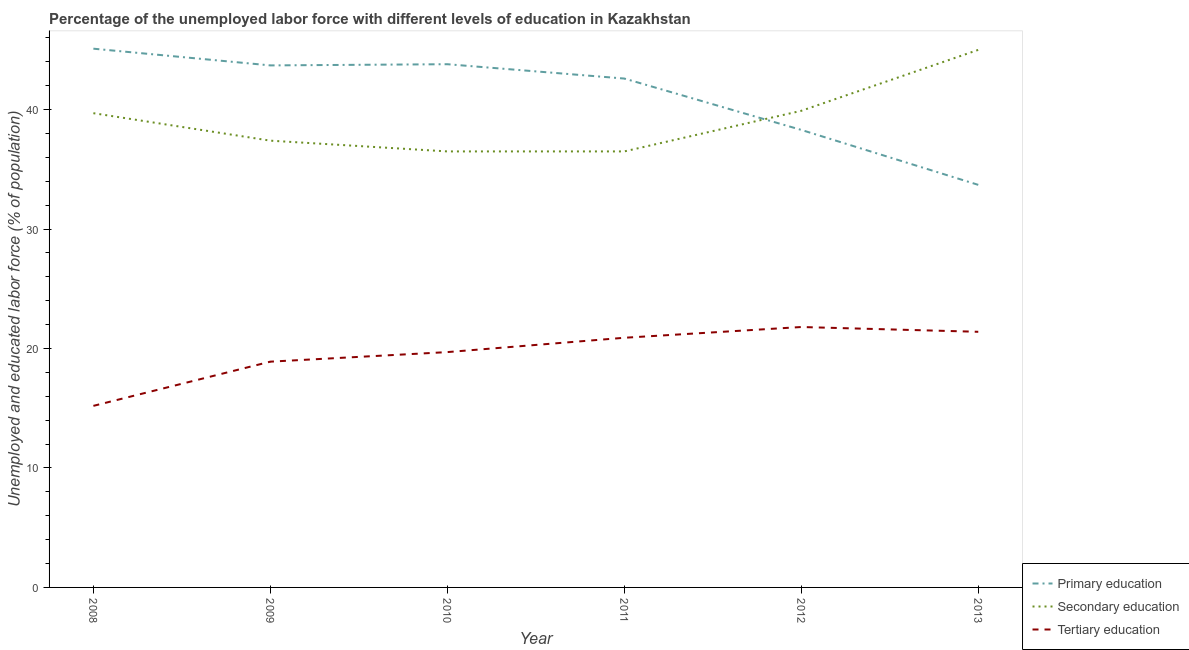Does the line corresponding to percentage of labor force who received tertiary education intersect with the line corresponding to percentage of labor force who received secondary education?
Offer a terse response. No. Is the number of lines equal to the number of legend labels?
Give a very brief answer. Yes. What is the percentage of labor force who received primary education in 2008?
Provide a short and direct response. 45.1. Across all years, what is the maximum percentage of labor force who received tertiary education?
Make the answer very short. 21.8. Across all years, what is the minimum percentage of labor force who received tertiary education?
Ensure brevity in your answer.  15.2. In which year was the percentage of labor force who received primary education maximum?
Offer a very short reply. 2008. What is the total percentage of labor force who received primary education in the graph?
Your answer should be very brief. 247.2. What is the difference between the percentage of labor force who received primary education in 2012 and that in 2013?
Ensure brevity in your answer.  4.6. What is the difference between the percentage of labor force who received tertiary education in 2012 and the percentage of labor force who received secondary education in 2009?
Your answer should be compact. -15.6. What is the average percentage of labor force who received secondary education per year?
Provide a succinct answer. 39.17. In the year 2011, what is the difference between the percentage of labor force who received secondary education and percentage of labor force who received primary education?
Give a very brief answer. -6.1. In how many years, is the percentage of labor force who received secondary education greater than 4 %?
Keep it short and to the point. 6. What is the ratio of the percentage of labor force who received tertiary education in 2010 to that in 2012?
Make the answer very short. 0.9. What is the difference between the highest and the second highest percentage of labor force who received tertiary education?
Give a very brief answer. 0.4. What is the difference between the highest and the lowest percentage of labor force who received tertiary education?
Offer a terse response. 6.6. In how many years, is the percentage of labor force who received primary education greater than the average percentage of labor force who received primary education taken over all years?
Ensure brevity in your answer.  4. Is the sum of the percentage of labor force who received secondary education in 2010 and 2011 greater than the maximum percentage of labor force who received tertiary education across all years?
Your answer should be very brief. Yes. Is it the case that in every year, the sum of the percentage of labor force who received primary education and percentage of labor force who received secondary education is greater than the percentage of labor force who received tertiary education?
Provide a short and direct response. Yes. How many lines are there?
Offer a very short reply. 3. How many years are there in the graph?
Give a very brief answer. 6. Are the values on the major ticks of Y-axis written in scientific E-notation?
Provide a short and direct response. No. Does the graph contain any zero values?
Give a very brief answer. No. Where does the legend appear in the graph?
Your answer should be compact. Bottom right. How many legend labels are there?
Offer a terse response. 3. What is the title of the graph?
Provide a short and direct response. Percentage of the unemployed labor force with different levels of education in Kazakhstan. What is the label or title of the Y-axis?
Offer a very short reply. Unemployed and educated labor force (% of population). What is the Unemployed and educated labor force (% of population) of Primary education in 2008?
Keep it short and to the point. 45.1. What is the Unemployed and educated labor force (% of population) in Secondary education in 2008?
Ensure brevity in your answer.  39.7. What is the Unemployed and educated labor force (% of population) in Tertiary education in 2008?
Offer a terse response. 15.2. What is the Unemployed and educated labor force (% of population) of Primary education in 2009?
Your answer should be compact. 43.7. What is the Unemployed and educated labor force (% of population) of Secondary education in 2009?
Offer a very short reply. 37.4. What is the Unemployed and educated labor force (% of population) in Tertiary education in 2009?
Your answer should be compact. 18.9. What is the Unemployed and educated labor force (% of population) in Primary education in 2010?
Provide a short and direct response. 43.8. What is the Unemployed and educated labor force (% of population) of Secondary education in 2010?
Ensure brevity in your answer.  36.5. What is the Unemployed and educated labor force (% of population) of Tertiary education in 2010?
Your response must be concise. 19.7. What is the Unemployed and educated labor force (% of population) of Primary education in 2011?
Offer a very short reply. 42.6. What is the Unemployed and educated labor force (% of population) in Secondary education in 2011?
Give a very brief answer. 36.5. What is the Unemployed and educated labor force (% of population) of Tertiary education in 2011?
Offer a very short reply. 20.9. What is the Unemployed and educated labor force (% of population) in Primary education in 2012?
Your answer should be very brief. 38.3. What is the Unemployed and educated labor force (% of population) in Secondary education in 2012?
Your answer should be very brief. 39.9. What is the Unemployed and educated labor force (% of population) of Tertiary education in 2012?
Provide a short and direct response. 21.8. What is the Unemployed and educated labor force (% of population) of Primary education in 2013?
Provide a short and direct response. 33.7. What is the Unemployed and educated labor force (% of population) in Secondary education in 2013?
Make the answer very short. 45. What is the Unemployed and educated labor force (% of population) in Tertiary education in 2013?
Make the answer very short. 21.4. Across all years, what is the maximum Unemployed and educated labor force (% of population) of Primary education?
Your response must be concise. 45.1. Across all years, what is the maximum Unemployed and educated labor force (% of population) of Secondary education?
Make the answer very short. 45. Across all years, what is the maximum Unemployed and educated labor force (% of population) of Tertiary education?
Your response must be concise. 21.8. Across all years, what is the minimum Unemployed and educated labor force (% of population) in Primary education?
Keep it short and to the point. 33.7. Across all years, what is the minimum Unemployed and educated labor force (% of population) of Secondary education?
Offer a very short reply. 36.5. Across all years, what is the minimum Unemployed and educated labor force (% of population) in Tertiary education?
Make the answer very short. 15.2. What is the total Unemployed and educated labor force (% of population) in Primary education in the graph?
Provide a succinct answer. 247.2. What is the total Unemployed and educated labor force (% of population) in Secondary education in the graph?
Provide a succinct answer. 235. What is the total Unemployed and educated labor force (% of population) of Tertiary education in the graph?
Provide a succinct answer. 117.9. What is the difference between the Unemployed and educated labor force (% of population) in Primary education in 2008 and that in 2009?
Your answer should be compact. 1.4. What is the difference between the Unemployed and educated labor force (% of population) in Secondary education in 2008 and that in 2009?
Make the answer very short. 2.3. What is the difference between the Unemployed and educated labor force (% of population) in Primary education in 2008 and that in 2010?
Give a very brief answer. 1.3. What is the difference between the Unemployed and educated labor force (% of population) of Tertiary education in 2008 and that in 2010?
Offer a very short reply. -4.5. What is the difference between the Unemployed and educated labor force (% of population) in Primary education in 2008 and that in 2011?
Make the answer very short. 2.5. What is the difference between the Unemployed and educated labor force (% of population) in Secondary education in 2008 and that in 2011?
Offer a very short reply. 3.2. What is the difference between the Unemployed and educated labor force (% of population) of Secondary education in 2008 and that in 2013?
Provide a succinct answer. -5.3. What is the difference between the Unemployed and educated labor force (% of population) of Primary education in 2009 and that in 2010?
Offer a terse response. -0.1. What is the difference between the Unemployed and educated labor force (% of population) in Secondary education in 2009 and that in 2010?
Provide a succinct answer. 0.9. What is the difference between the Unemployed and educated labor force (% of population) of Tertiary education in 2009 and that in 2010?
Offer a terse response. -0.8. What is the difference between the Unemployed and educated labor force (% of population) of Primary education in 2009 and that in 2012?
Ensure brevity in your answer.  5.4. What is the difference between the Unemployed and educated labor force (% of population) of Secondary education in 2009 and that in 2012?
Offer a terse response. -2.5. What is the difference between the Unemployed and educated labor force (% of population) of Secondary education in 2010 and that in 2011?
Ensure brevity in your answer.  0. What is the difference between the Unemployed and educated labor force (% of population) of Primary education in 2010 and that in 2012?
Provide a short and direct response. 5.5. What is the difference between the Unemployed and educated labor force (% of population) of Secondary education in 2010 and that in 2012?
Your answer should be very brief. -3.4. What is the difference between the Unemployed and educated labor force (% of population) in Tertiary education in 2010 and that in 2012?
Provide a succinct answer. -2.1. What is the difference between the Unemployed and educated labor force (% of population) in Tertiary education in 2010 and that in 2013?
Offer a terse response. -1.7. What is the difference between the Unemployed and educated labor force (% of population) in Primary education in 2011 and that in 2012?
Your answer should be compact. 4.3. What is the difference between the Unemployed and educated labor force (% of population) of Secondary education in 2011 and that in 2012?
Ensure brevity in your answer.  -3.4. What is the difference between the Unemployed and educated labor force (% of population) in Tertiary education in 2011 and that in 2012?
Keep it short and to the point. -0.9. What is the difference between the Unemployed and educated labor force (% of population) of Primary education in 2011 and that in 2013?
Offer a very short reply. 8.9. What is the difference between the Unemployed and educated labor force (% of population) in Secondary education in 2011 and that in 2013?
Give a very brief answer. -8.5. What is the difference between the Unemployed and educated labor force (% of population) of Tertiary education in 2011 and that in 2013?
Provide a succinct answer. -0.5. What is the difference between the Unemployed and educated labor force (% of population) of Primary education in 2012 and that in 2013?
Give a very brief answer. 4.6. What is the difference between the Unemployed and educated labor force (% of population) of Secondary education in 2012 and that in 2013?
Ensure brevity in your answer.  -5.1. What is the difference between the Unemployed and educated labor force (% of population) of Primary education in 2008 and the Unemployed and educated labor force (% of population) of Secondary education in 2009?
Provide a succinct answer. 7.7. What is the difference between the Unemployed and educated labor force (% of population) in Primary education in 2008 and the Unemployed and educated labor force (% of population) in Tertiary education in 2009?
Make the answer very short. 26.2. What is the difference between the Unemployed and educated labor force (% of population) of Secondary education in 2008 and the Unemployed and educated labor force (% of population) of Tertiary education in 2009?
Provide a succinct answer. 20.8. What is the difference between the Unemployed and educated labor force (% of population) in Primary education in 2008 and the Unemployed and educated labor force (% of population) in Secondary education in 2010?
Make the answer very short. 8.6. What is the difference between the Unemployed and educated labor force (% of population) of Primary education in 2008 and the Unemployed and educated labor force (% of population) of Tertiary education in 2010?
Provide a succinct answer. 25.4. What is the difference between the Unemployed and educated labor force (% of population) in Secondary education in 2008 and the Unemployed and educated labor force (% of population) in Tertiary education in 2010?
Your answer should be very brief. 20. What is the difference between the Unemployed and educated labor force (% of population) in Primary education in 2008 and the Unemployed and educated labor force (% of population) in Tertiary education in 2011?
Ensure brevity in your answer.  24.2. What is the difference between the Unemployed and educated labor force (% of population) in Secondary education in 2008 and the Unemployed and educated labor force (% of population) in Tertiary education in 2011?
Ensure brevity in your answer.  18.8. What is the difference between the Unemployed and educated labor force (% of population) of Primary education in 2008 and the Unemployed and educated labor force (% of population) of Tertiary education in 2012?
Offer a very short reply. 23.3. What is the difference between the Unemployed and educated labor force (% of population) of Secondary education in 2008 and the Unemployed and educated labor force (% of population) of Tertiary education in 2012?
Offer a terse response. 17.9. What is the difference between the Unemployed and educated labor force (% of population) of Primary education in 2008 and the Unemployed and educated labor force (% of population) of Tertiary education in 2013?
Ensure brevity in your answer.  23.7. What is the difference between the Unemployed and educated labor force (% of population) of Secondary education in 2008 and the Unemployed and educated labor force (% of population) of Tertiary education in 2013?
Your answer should be very brief. 18.3. What is the difference between the Unemployed and educated labor force (% of population) in Primary education in 2009 and the Unemployed and educated labor force (% of population) in Secondary education in 2010?
Give a very brief answer. 7.2. What is the difference between the Unemployed and educated labor force (% of population) in Primary education in 2009 and the Unemployed and educated labor force (% of population) in Tertiary education in 2010?
Offer a terse response. 24. What is the difference between the Unemployed and educated labor force (% of population) in Primary education in 2009 and the Unemployed and educated labor force (% of population) in Secondary education in 2011?
Your response must be concise. 7.2. What is the difference between the Unemployed and educated labor force (% of population) of Primary education in 2009 and the Unemployed and educated labor force (% of population) of Tertiary education in 2011?
Provide a short and direct response. 22.8. What is the difference between the Unemployed and educated labor force (% of population) in Secondary education in 2009 and the Unemployed and educated labor force (% of population) in Tertiary education in 2011?
Offer a terse response. 16.5. What is the difference between the Unemployed and educated labor force (% of population) of Primary education in 2009 and the Unemployed and educated labor force (% of population) of Tertiary education in 2012?
Offer a terse response. 21.9. What is the difference between the Unemployed and educated labor force (% of population) in Primary education in 2009 and the Unemployed and educated labor force (% of population) in Secondary education in 2013?
Offer a terse response. -1.3. What is the difference between the Unemployed and educated labor force (% of population) in Primary education in 2009 and the Unemployed and educated labor force (% of population) in Tertiary education in 2013?
Your response must be concise. 22.3. What is the difference between the Unemployed and educated labor force (% of population) in Secondary education in 2009 and the Unemployed and educated labor force (% of population) in Tertiary education in 2013?
Your response must be concise. 16. What is the difference between the Unemployed and educated labor force (% of population) in Primary education in 2010 and the Unemployed and educated labor force (% of population) in Secondary education in 2011?
Offer a terse response. 7.3. What is the difference between the Unemployed and educated labor force (% of population) in Primary education in 2010 and the Unemployed and educated labor force (% of population) in Tertiary education in 2011?
Provide a short and direct response. 22.9. What is the difference between the Unemployed and educated labor force (% of population) in Secondary education in 2010 and the Unemployed and educated labor force (% of population) in Tertiary education in 2011?
Provide a succinct answer. 15.6. What is the difference between the Unemployed and educated labor force (% of population) of Primary education in 2010 and the Unemployed and educated labor force (% of population) of Secondary education in 2012?
Provide a succinct answer. 3.9. What is the difference between the Unemployed and educated labor force (% of population) of Primary education in 2010 and the Unemployed and educated labor force (% of population) of Secondary education in 2013?
Make the answer very short. -1.2. What is the difference between the Unemployed and educated labor force (% of population) in Primary education in 2010 and the Unemployed and educated labor force (% of population) in Tertiary education in 2013?
Provide a succinct answer. 22.4. What is the difference between the Unemployed and educated labor force (% of population) of Primary education in 2011 and the Unemployed and educated labor force (% of population) of Secondary education in 2012?
Ensure brevity in your answer.  2.7. What is the difference between the Unemployed and educated labor force (% of population) in Primary education in 2011 and the Unemployed and educated labor force (% of population) in Tertiary education in 2012?
Make the answer very short. 20.8. What is the difference between the Unemployed and educated labor force (% of population) of Secondary education in 2011 and the Unemployed and educated labor force (% of population) of Tertiary education in 2012?
Your answer should be compact. 14.7. What is the difference between the Unemployed and educated labor force (% of population) of Primary education in 2011 and the Unemployed and educated labor force (% of population) of Tertiary education in 2013?
Ensure brevity in your answer.  21.2. What is the average Unemployed and educated labor force (% of population) of Primary education per year?
Provide a short and direct response. 41.2. What is the average Unemployed and educated labor force (% of population) of Secondary education per year?
Make the answer very short. 39.17. What is the average Unemployed and educated labor force (% of population) in Tertiary education per year?
Your response must be concise. 19.65. In the year 2008, what is the difference between the Unemployed and educated labor force (% of population) in Primary education and Unemployed and educated labor force (% of population) in Tertiary education?
Give a very brief answer. 29.9. In the year 2008, what is the difference between the Unemployed and educated labor force (% of population) of Secondary education and Unemployed and educated labor force (% of population) of Tertiary education?
Provide a succinct answer. 24.5. In the year 2009, what is the difference between the Unemployed and educated labor force (% of population) of Primary education and Unemployed and educated labor force (% of population) of Tertiary education?
Offer a very short reply. 24.8. In the year 2009, what is the difference between the Unemployed and educated labor force (% of population) in Secondary education and Unemployed and educated labor force (% of population) in Tertiary education?
Provide a short and direct response. 18.5. In the year 2010, what is the difference between the Unemployed and educated labor force (% of population) of Primary education and Unemployed and educated labor force (% of population) of Secondary education?
Keep it short and to the point. 7.3. In the year 2010, what is the difference between the Unemployed and educated labor force (% of population) in Primary education and Unemployed and educated labor force (% of population) in Tertiary education?
Make the answer very short. 24.1. In the year 2010, what is the difference between the Unemployed and educated labor force (% of population) of Secondary education and Unemployed and educated labor force (% of population) of Tertiary education?
Give a very brief answer. 16.8. In the year 2011, what is the difference between the Unemployed and educated labor force (% of population) in Primary education and Unemployed and educated labor force (% of population) in Tertiary education?
Give a very brief answer. 21.7. In the year 2012, what is the difference between the Unemployed and educated labor force (% of population) in Primary education and Unemployed and educated labor force (% of population) in Secondary education?
Your answer should be very brief. -1.6. In the year 2012, what is the difference between the Unemployed and educated labor force (% of population) in Primary education and Unemployed and educated labor force (% of population) in Tertiary education?
Provide a short and direct response. 16.5. In the year 2012, what is the difference between the Unemployed and educated labor force (% of population) of Secondary education and Unemployed and educated labor force (% of population) of Tertiary education?
Offer a terse response. 18.1. In the year 2013, what is the difference between the Unemployed and educated labor force (% of population) of Secondary education and Unemployed and educated labor force (% of population) of Tertiary education?
Give a very brief answer. 23.6. What is the ratio of the Unemployed and educated labor force (% of population) in Primary education in 2008 to that in 2009?
Your answer should be compact. 1.03. What is the ratio of the Unemployed and educated labor force (% of population) in Secondary education in 2008 to that in 2009?
Your answer should be compact. 1.06. What is the ratio of the Unemployed and educated labor force (% of population) of Tertiary education in 2008 to that in 2009?
Provide a succinct answer. 0.8. What is the ratio of the Unemployed and educated labor force (% of population) of Primary education in 2008 to that in 2010?
Provide a succinct answer. 1.03. What is the ratio of the Unemployed and educated labor force (% of population) of Secondary education in 2008 to that in 2010?
Your response must be concise. 1.09. What is the ratio of the Unemployed and educated labor force (% of population) of Tertiary education in 2008 to that in 2010?
Ensure brevity in your answer.  0.77. What is the ratio of the Unemployed and educated labor force (% of population) in Primary education in 2008 to that in 2011?
Keep it short and to the point. 1.06. What is the ratio of the Unemployed and educated labor force (% of population) of Secondary education in 2008 to that in 2011?
Your answer should be compact. 1.09. What is the ratio of the Unemployed and educated labor force (% of population) in Tertiary education in 2008 to that in 2011?
Make the answer very short. 0.73. What is the ratio of the Unemployed and educated labor force (% of population) of Primary education in 2008 to that in 2012?
Ensure brevity in your answer.  1.18. What is the ratio of the Unemployed and educated labor force (% of population) in Secondary education in 2008 to that in 2012?
Offer a terse response. 0.99. What is the ratio of the Unemployed and educated labor force (% of population) of Tertiary education in 2008 to that in 2012?
Offer a very short reply. 0.7. What is the ratio of the Unemployed and educated labor force (% of population) of Primary education in 2008 to that in 2013?
Offer a terse response. 1.34. What is the ratio of the Unemployed and educated labor force (% of population) in Secondary education in 2008 to that in 2013?
Your answer should be very brief. 0.88. What is the ratio of the Unemployed and educated labor force (% of population) of Tertiary education in 2008 to that in 2013?
Keep it short and to the point. 0.71. What is the ratio of the Unemployed and educated labor force (% of population) of Primary education in 2009 to that in 2010?
Keep it short and to the point. 1. What is the ratio of the Unemployed and educated labor force (% of population) in Secondary education in 2009 to that in 2010?
Your answer should be very brief. 1.02. What is the ratio of the Unemployed and educated labor force (% of population) of Tertiary education in 2009 to that in 2010?
Make the answer very short. 0.96. What is the ratio of the Unemployed and educated labor force (% of population) in Primary education in 2009 to that in 2011?
Offer a very short reply. 1.03. What is the ratio of the Unemployed and educated labor force (% of population) of Secondary education in 2009 to that in 2011?
Offer a very short reply. 1.02. What is the ratio of the Unemployed and educated labor force (% of population) in Tertiary education in 2009 to that in 2011?
Provide a succinct answer. 0.9. What is the ratio of the Unemployed and educated labor force (% of population) in Primary education in 2009 to that in 2012?
Keep it short and to the point. 1.14. What is the ratio of the Unemployed and educated labor force (% of population) of Secondary education in 2009 to that in 2012?
Offer a terse response. 0.94. What is the ratio of the Unemployed and educated labor force (% of population) of Tertiary education in 2009 to that in 2012?
Your answer should be very brief. 0.87. What is the ratio of the Unemployed and educated labor force (% of population) of Primary education in 2009 to that in 2013?
Ensure brevity in your answer.  1.3. What is the ratio of the Unemployed and educated labor force (% of population) in Secondary education in 2009 to that in 2013?
Ensure brevity in your answer.  0.83. What is the ratio of the Unemployed and educated labor force (% of population) of Tertiary education in 2009 to that in 2013?
Your response must be concise. 0.88. What is the ratio of the Unemployed and educated labor force (% of population) in Primary education in 2010 to that in 2011?
Provide a short and direct response. 1.03. What is the ratio of the Unemployed and educated labor force (% of population) of Secondary education in 2010 to that in 2011?
Your answer should be compact. 1. What is the ratio of the Unemployed and educated labor force (% of population) of Tertiary education in 2010 to that in 2011?
Ensure brevity in your answer.  0.94. What is the ratio of the Unemployed and educated labor force (% of population) of Primary education in 2010 to that in 2012?
Ensure brevity in your answer.  1.14. What is the ratio of the Unemployed and educated labor force (% of population) of Secondary education in 2010 to that in 2012?
Make the answer very short. 0.91. What is the ratio of the Unemployed and educated labor force (% of population) of Tertiary education in 2010 to that in 2012?
Offer a terse response. 0.9. What is the ratio of the Unemployed and educated labor force (% of population) in Primary education in 2010 to that in 2013?
Give a very brief answer. 1.3. What is the ratio of the Unemployed and educated labor force (% of population) in Secondary education in 2010 to that in 2013?
Offer a very short reply. 0.81. What is the ratio of the Unemployed and educated labor force (% of population) of Tertiary education in 2010 to that in 2013?
Provide a short and direct response. 0.92. What is the ratio of the Unemployed and educated labor force (% of population) of Primary education in 2011 to that in 2012?
Keep it short and to the point. 1.11. What is the ratio of the Unemployed and educated labor force (% of population) in Secondary education in 2011 to that in 2012?
Your answer should be very brief. 0.91. What is the ratio of the Unemployed and educated labor force (% of population) of Tertiary education in 2011 to that in 2012?
Your answer should be very brief. 0.96. What is the ratio of the Unemployed and educated labor force (% of population) in Primary education in 2011 to that in 2013?
Make the answer very short. 1.26. What is the ratio of the Unemployed and educated labor force (% of population) in Secondary education in 2011 to that in 2013?
Provide a short and direct response. 0.81. What is the ratio of the Unemployed and educated labor force (% of population) of Tertiary education in 2011 to that in 2013?
Your response must be concise. 0.98. What is the ratio of the Unemployed and educated labor force (% of population) in Primary education in 2012 to that in 2013?
Provide a succinct answer. 1.14. What is the ratio of the Unemployed and educated labor force (% of population) in Secondary education in 2012 to that in 2013?
Your response must be concise. 0.89. What is the ratio of the Unemployed and educated labor force (% of population) of Tertiary education in 2012 to that in 2013?
Give a very brief answer. 1.02. What is the difference between the highest and the second highest Unemployed and educated labor force (% of population) of Secondary education?
Your response must be concise. 5.1. What is the difference between the highest and the second highest Unemployed and educated labor force (% of population) of Tertiary education?
Offer a very short reply. 0.4. What is the difference between the highest and the lowest Unemployed and educated labor force (% of population) in Primary education?
Provide a short and direct response. 11.4. What is the difference between the highest and the lowest Unemployed and educated labor force (% of population) in Tertiary education?
Provide a short and direct response. 6.6. 